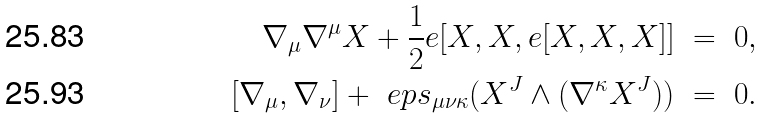<formula> <loc_0><loc_0><loc_500><loc_500>\nabla _ { \mu } \nabla ^ { \mu } X + \frac { 1 } { 2 } e [ X , X , e [ X , X , X ] ] & \ = \ 0 , \\ [ \nabla _ { \mu } , \nabla _ { \nu } ] + \ e p s _ { \mu \nu \kappa } ( X ^ { J } \wedge ( \nabla ^ { \kappa } X ^ { J } ) ) & \ = \ 0 .</formula> 